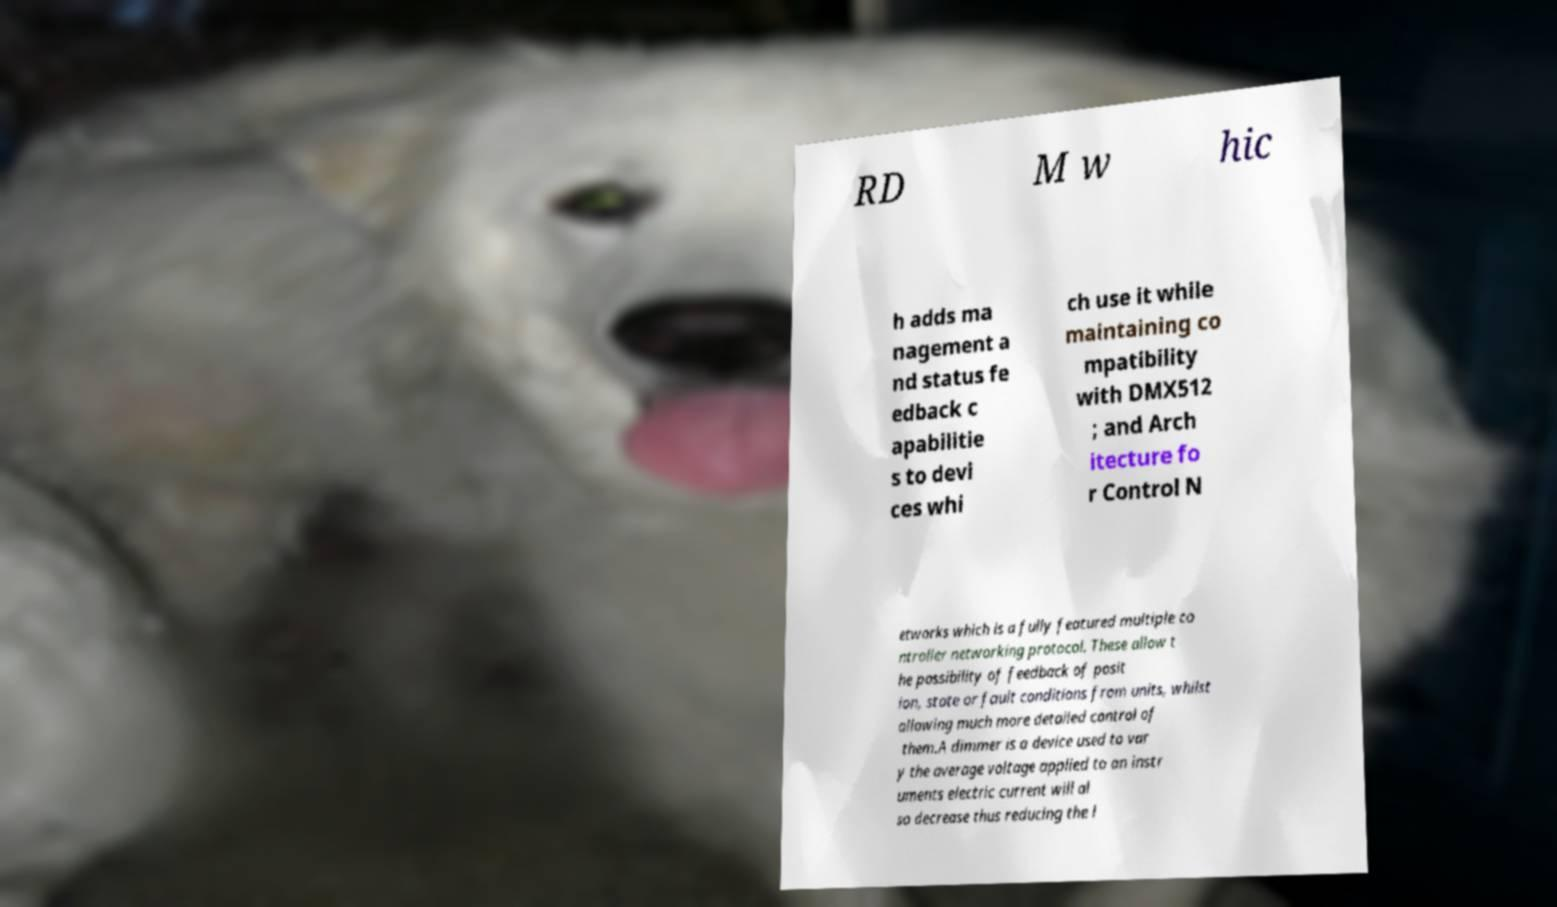What messages or text are displayed in this image? I need them in a readable, typed format. RD M w hic h adds ma nagement a nd status fe edback c apabilitie s to devi ces whi ch use it while maintaining co mpatibility with DMX512 ; and Arch itecture fo r Control N etworks which is a fully featured multiple co ntroller networking protocol. These allow t he possibility of feedback of posit ion, state or fault conditions from units, whilst allowing much more detailed control of them.A dimmer is a device used to var y the average voltage applied to an instr uments electric current will al so decrease thus reducing the l 